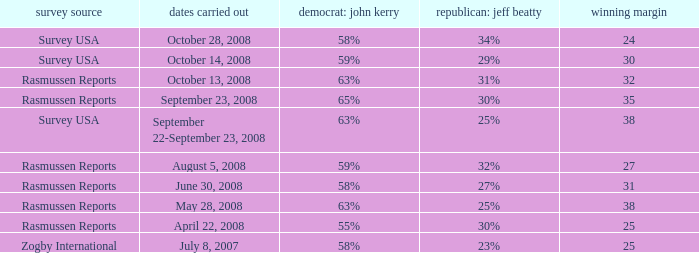What percent is the lead margin of 25 that Republican: Jeff Beatty has according to poll source Rasmussen Reports? 30%. 